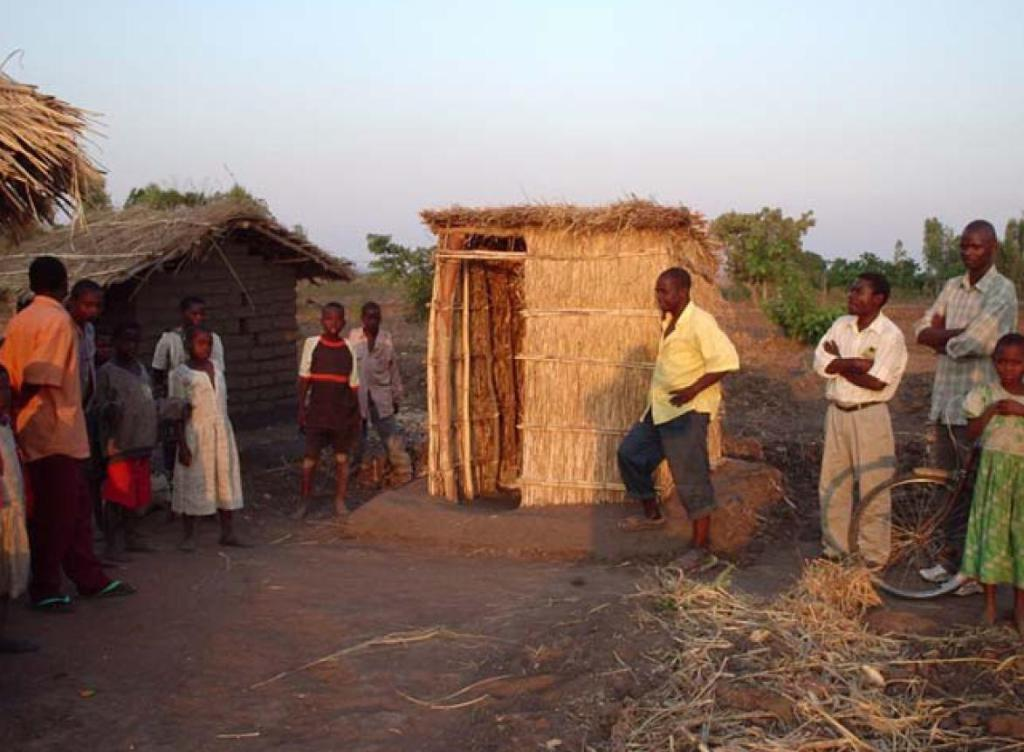What is the primary setting of the image? There are people standing on the land in the image. Can you describe the gender distribution of the people in the image? Most of the people in the image are men. What type of structures can be seen in the image? There are huts in the image. What can be seen in the background of the image? There are trees and the sky visible in the background of the image. What type of popcorn is being served in the image? There is no popcorn present in the image. How many sacks are visible in the image? There are no sacks visible in the image. 